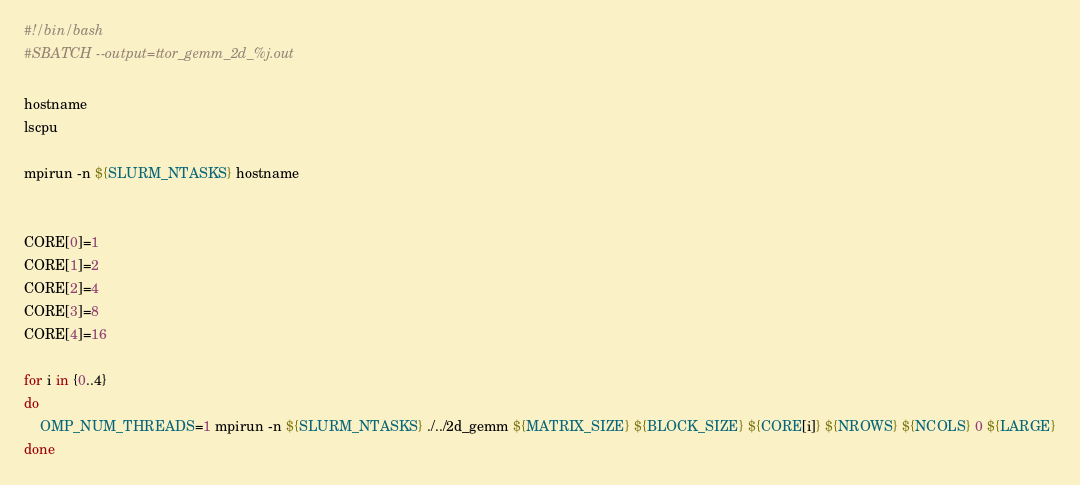Convert code to text. <code><loc_0><loc_0><loc_500><loc_500><_Bash_>#!/bin/bash
#SBATCH --output=ttor_gemm_2d_%j.out

hostname
lscpu

mpirun -n ${SLURM_NTASKS} hostname


CORE[0]=1
CORE[1]=2
CORE[2]=4
CORE[3]=8
CORE[4]=16

for i in {0..4}
do
    OMP_NUM_THREADS=1 mpirun -n ${SLURM_NTASKS} ./../2d_gemm ${MATRIX_SIZE} ${BLOCK_SIZE} ${CORE[i]} ${NROWS} ${NCOLS} 0 ${LARGE}
done
</code> 